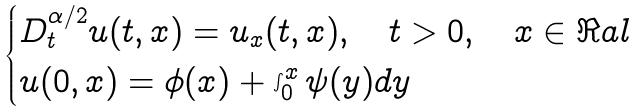<formula> <loc_0><loc_0><loc_500><loc_500>\begin{cases} D _ { t } ^ { \alpha / 2 } u ( t , x ) = u _ { x } ( t , x ) , \quad t > 0 , \quad x \in \Re a l \\ u ( 0 , x ) = \phi ( x ) + \int _ { 0 } ^ { x } \psi ( y ) d y \end{cases}</formula> 